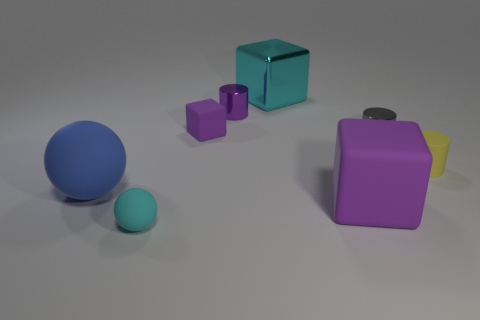Add 1 matte cylinders. How many objects exist? 9 Subtract all blocks. How many objects are left? 5 Subtract 0 gray spheres. How many objects are left? 8 Subtract all small yellow cylinders. Subtract all large cyan shiny objects. How many objects are left? 6 Add 1 small purple shiny objects. How many small purple shiny objects are left? 2 Add 4 large spheres. How many large spheres exist? 5 